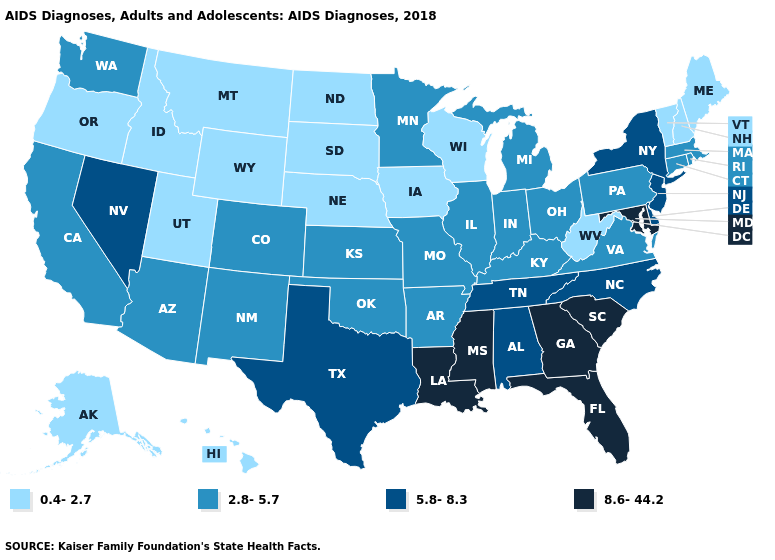What is the lowest value in the West?
Quick response, please. 0.4-2.7. How many symbols are there in the legend?
Answer briefly. 4. What is the value of Delaware?
Write a very short answer. 5.8-8.3. What is the highest value in states that border Georgia?
Quick response, please. 8.6-44.2. What is the highest value in the South ?
Keep it brief. 8.6-44.2. What is the value of Nebraska?
Quick response, please. 0.4-2.7. Does South Carolina have a higher value than Georgia?
Be succinct. No. What is the value of Vermont?
Write a very short answer. 0.4-2.7. Does West Virginia have a higher value than Maryland?
Short answer required. No. Among the states that border Kentucky , does Tennessee have the highest value?
Keep it brief. Yes. Does the map have missing data?
Be succinct. No. What is the highest value in the USA?
Give a very brief answer. 8.6-44.2. Which states have the highest value in the USA?
Concise answer only. Florida, Georgia, Louisiana, Maryland, Mississippi, South Carolina. Does Wisconsin have the lowest value in the USA?
Be succinct. Yes. What is the lowest value in states that border North Dakota?
Write a very short answer. 0.4-2.7. 